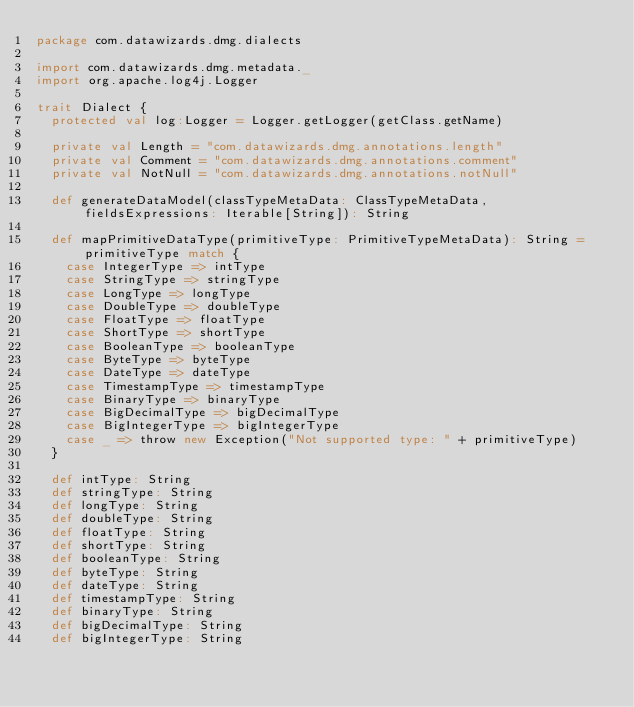Convert code to text. <code><loc_0><loc_0><loc_500><loc_500><_Scala_>package com.datawizards.dmg.dialects

import com.datawizards.dmg.metadata._
import org.apache.log4j.Logger

trait Dialect {
  protected val log:Logger = Logger.getLogger(getClass.getName)

  private val Length = "com.datawizards.dmg.annotations.length"
  private val Comment = "com.datawizards.dmg.annotations.comment"
  private val NotNull = "com.datawizards.dmg.annotations.notNull"

  def generateDataModel(classTypeMetaData: ClassTypeMetaData, fieldsExpressions: Iterable[String]): String

  def mapPrimitiveDataType(primitiveType: PrimitiveTypeMetaData): String = primitiveType match {
    case IntegerType => intType
    case StringType => stringType
    case LongType => longType
    case DoubleType => doubleType
    case FloatType => floatType
    case ShortType => shortType
    case BooleanType => booleanType
    case ByteType => byteType
    case DateType => dateType
    case TimestampType => timestampType
    case BinaryType => binaryType
    case BigDecimalType => bigDecimalType
    case BigIntegerType => bigIntegerType
    case _ => throw new Exception("Not supported type: " + primitiveType)
  }

  def intType: String
  def stringType: String
  def longType: String
  def doubleType: String
  def floatType: String
  def shortType: String
  def booleanType: String
  def byteType: String
  def dateType: String
  def timestampType: String
  def binaryType: String
  def bigDecimalType: String
  def bigIntegerType: String
</code> 